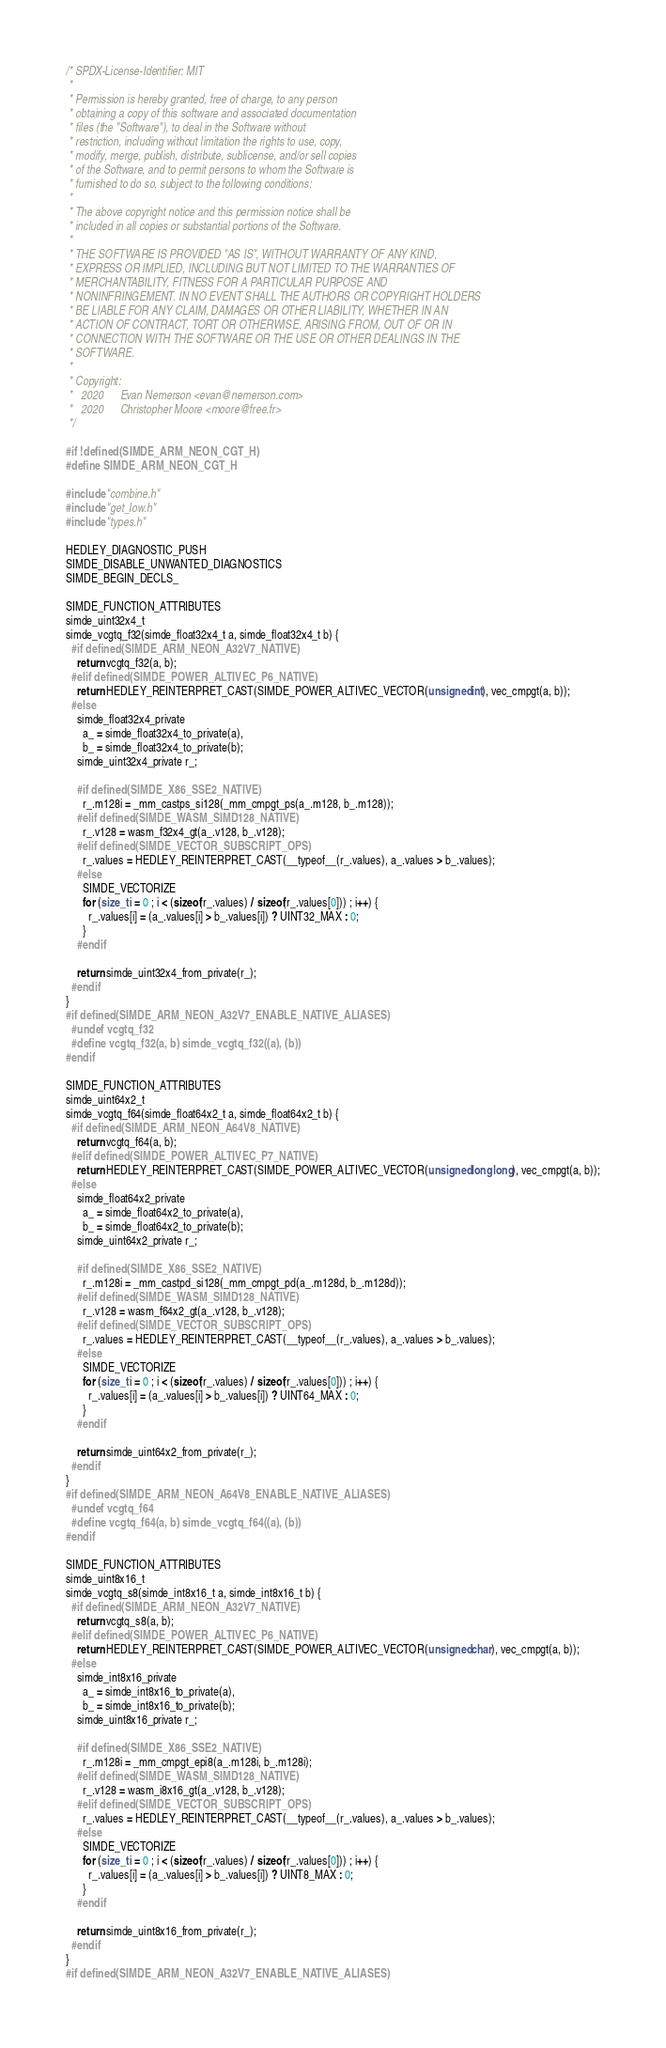Convert code to text. <code><loc_0><loc_0><loc_500><loc_500><_C_>/* SPDX-License-Identifier: MIT
 *
 * Permission is hereby granted, free of charge, to any person
 * obtaining a copy of this software and associated documentation
 * files (the "Software"), to deal in the Software without
 * restriction, including without limitation the rights to use, copy,
 * modify, merge, publish, distribute, sublicense, and/or sell copies
 * of the Software, and to permit persons to whom the Software is
 * furnished to do so, subject to the following conditions:
 *
 * The above copyright notice and this permission notice shall be
 * included in all copies or substantial portions of the Software.
 *
 * THE SOFTWARE IS PROVIDED "AS IS", WITHOUT WARRANTY OF ANY KIND,
 * EXPRESS OR IMPLIED, INCLUDING BUT NOT LIMITED TO THE WARRANTIES OF
 * MERCHANTABILITY, FITNESS FOR A PARTICULAR PURPOSE AND
 * NONINFRINGEMENT. IN NO EVENT SHALL THE AUTHORS OR COPYRIGHT HOLDERS
 * BE LIABLE FOR ANY CLAIM, DAMAGES OR OTHER LIABILITY, WHETHER IN AN
 * ACTION OF CONTRACT, TORT OR OTHERWISE, ARISING FROM, OUT OF OR IN
 * CONNECTION WITH THE SOFTWARE OR THE USE OR OTHER DEALINGS IN THE
 * SOFTWARE.
 *
 * Copyright:
 *   2020      Evan Nemerson <evan@nemerson.com>
 *   2020      Christopher Moore <moore@free.fr>
 */

#if !defined(SIMDE_ARM_NEON_CGT_H)
#define SIMDE_ARM_NEON_CGT_H

#include "combine.h"
#include "get_low.h"
#include "types.h"

HEDLEY_DIAGNOSTIC_PUSH
SIMDE_DISABLE_UNWANTED_DIAGNOSTICS
SIMDE_BEGIN_DECLS_

SIMDE_FUNCTION_ATTRIBUTES
simde_uint32x4_t
simde_vcgtq_f32(simde_float32x4_t a, simde_float32x4_t b) {
  #if defined(SIMDE_ARM_NEON_A32V7_NATIVE)
    return vcgtq_f32(a, b);
  #elif defined(SIMDE_POWER_ALTIVEC_P6_NATIVE)
    return HEDLEY_REINTERPRET_CAST(SIMDE_POWER_ALTIVEC_VECTOR(unsigned int), vec_cmpgt(a, b));
  #else
    simde_float32x4_private
      a_ = simde_float32x4_to_private(a),
      b_ = simde_float32x4_to_private(b);
    simde_uint32x4_private r_;

    #if defined(SIMDE_X86_SSE2_NATIVE)
      r_.m128i = _mm_castps_si128(_mm_cmpgt_ps(a_.m128, b_.m128));
    #elif defined(SIMDE_WASM_SIMD128_NATIVE)
      r_.v128 = wasm_f32x4_gt(a_.v128, b_.v128);
    #elif defined(SIMDE_VECTOR_SUBSCRIPT_OPS)
      r_.values = HEDLEY_REINTERPRET_CAST(__typeof__(r_.values), a_.values > b_.values);
    #else
      SIMDE_VECTORIZE
      for (size_t i = 0 ; i < (sizeof(r_.values) / sizeof(r_.values[0])) ; i++) {
        r_.values[i] = (a_.values[i] > b_.values[i]) ? UINT32_MAX : 0;
      }
    #endif

    return simde_uint32x4_from_private(r_);
  #endif
}
#if defined(SIMDE_ARM_NEON_A32V7_ENABLE_NATIVE_ALIASES)
  #undef vcgtq_f32
  #define vcgtq_f32(a, b) simde_vcgtq_f32((a), (b))
#endif

SIMDE_FUNCTION_ATTRIBUTES
simde_uint64x2_t
simde_vcgtq_f64(simde_float64x2_t a, simde_float64x2_t b) {
  #if defined(SIMDE_ARM_NEON_A64V8_NATIVE)
    return vcgtq_f64(a, b);
  #elif defined(SIMDE_POWER_ALTIVEC_P7_NATIVE)
    return HEDLEY_REINTERPRET_CAST(SIMDE_POWER_ALTIVEC_VECTOR(unsigned long long), vec_cmpgt(a, b));
  #else
    simde_float64x2_private
      a_ = simde_float64x2_to_private(a),
      b_ = simde_float64x2_to_private(b);
    simde_uint64x2_private r_;

    #if defined(SIMDE_X86_SSE2_NATIVE)
      r_.m128i = _mm_castpd_si128(_mm_cmpgt_pd(a_.m128d, b_.m128d));
    #elif defined(SIMDE_WASM_SIMD128_NATIVE)
      r_.v128 = wasm_f64x2_gt(a_.v128, b_.v128);
    #elif defined(SIMDE_VECTOR_SUBSCRIPT_OPS)
      r_.values = HEDLEY_REINTERPRET_CAST(__typeof__(r_.values), a_.values > b_.values);
    #else
      SIMDE_VECTORIZE
      for (size_t i = 0 ; i < (sizeof(r_.values) / sizeof(r_.values[0])) ; i++) {
        r_.values[i] = (a_.values[i] > b_.values[i]) ? UINT64_MAX : 0;
      }
    #endif

    return simde_uint64x2_from_private(r_);
  #endif
}
#if defined(SIMDE_ARM_NEON_A64V8_ENABLE_NATIVE_ALIASES)
  #undef vcgtq_f64
  #define vcgtq_f64(a, b) simde_vcgtq_f64((a), (b))
#endif

SIMDE_FUNCTION_ATTRIBUTES
simde_uint8x16_t
simde_vcgtq_s8(simde_int8x16_t a, simde_int8x16_t b) {
  #if defined(SIMDE_ARM_NEON_A32V7_NATIVE)
    return vcgtq_s8(a, b);
  #elif defined(SIMDE_POWER_ALTIVEC_P6_NATIVE)
    return HEDLEY_REINTERPRET_CAST(SIMDE_POWER_ALTIVEC_VECTOR(unsigned char), vec_cmpgt(a, b));
  #else
    simde_int8x16_private
      a_ = simde_int8x16_to_private(a),
      b_ = simde_int8x16_to_private(b);
    simde_uint8x16_private r_;

    #if defined(SIMDE_X86_SSE2_NATIVE)
      r_.m128i = _mm_cmpgt_epi8(a_.m128i, b_.m128i);
    #elif defined(SIMDE_WASM_SIMD128_NATIVE)
      r_.v128 = wasm_i8x16_gt(a_.v128, b_.v128);
    #elif defined(SIMDE_VECTOR_SUBSCRIPT_OPS)
      r_.values = HEDLEY_REINTERPRET_CAST(__typeof__(r_.values), a_.values > b_.values);
    #else
      SIMDE_VECTORIZE
      for (size_t i = 0 ; i < (sizeof(r_.values) / sizeof(r_.values[0])) ; i++) {
        r_.values[i] = (a_.values[i] > b_.values[i]) ? UINT8_MAX : 0;
      }
    #endif

    return simde_uint8x16_from_private(r_);
  #endif
}
#if defined(SIMDE_ARM_NEON_A32V7_ENABLE_NATIVE_ALIASES)</code> 